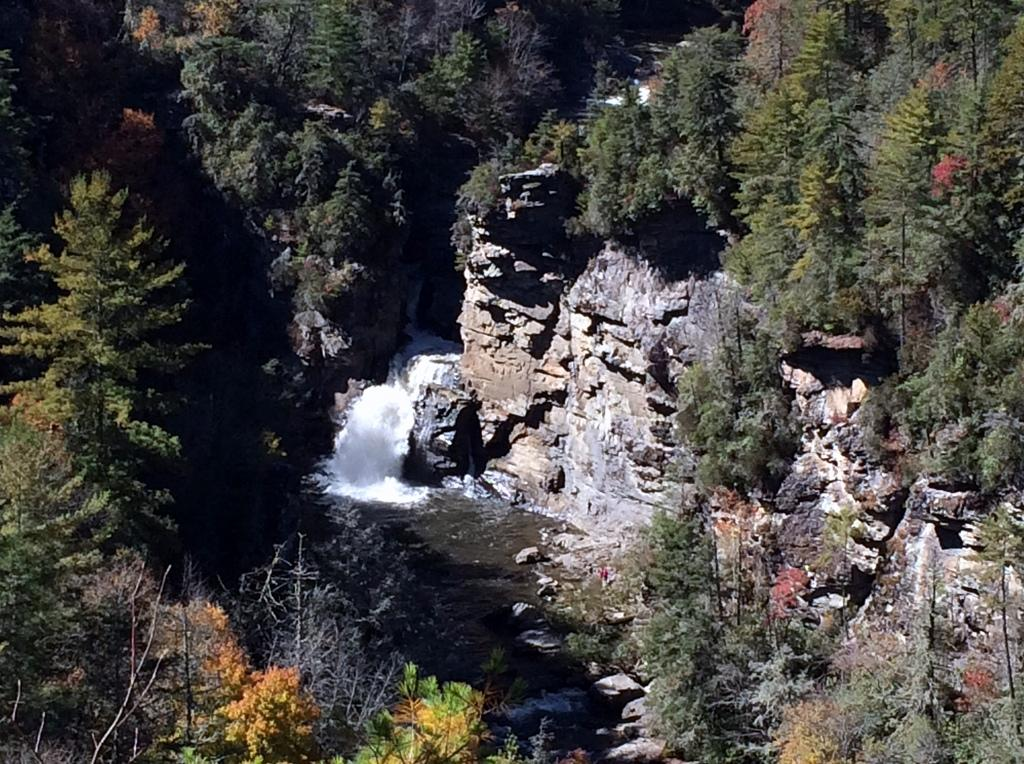What is the primary element visible in the image? There is water in the image. What other natural elements can be seen in the image? There are rocks and trees in the image. What type of frame surrounds the water in the image? There is no frame surrounding the water in the image. How does the water aid in the digestion process in the image? The image does not depict any digestion process, and the water is not related to digestion. 